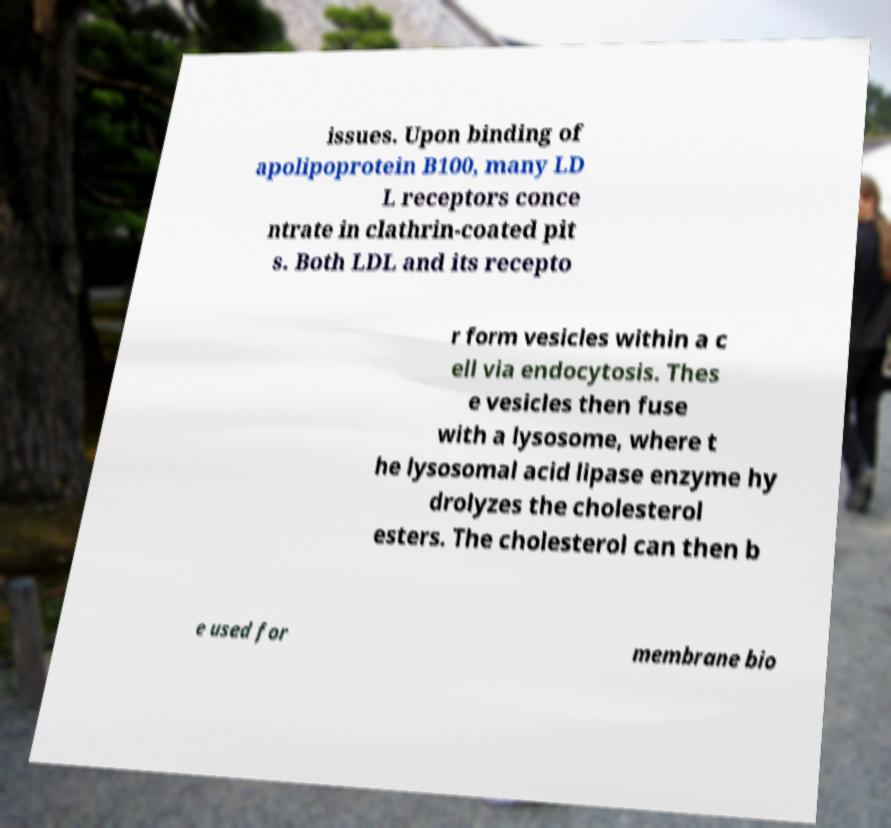Please read and relay the text visible in this image. What does it say? issues. Upon binding of apolipoprotein B100, many LD L receptors conce ntrate in clathrin-coated pit s. Both LDL and its recepto r form vesicles within a c ell via endocytosis. Thes e vesicles then fuse with a lysosome, where t he lysosomal acid lipase enzyme hy drolyzes the cholesterol esters. The cholesterol can then b e used for membrane bio 